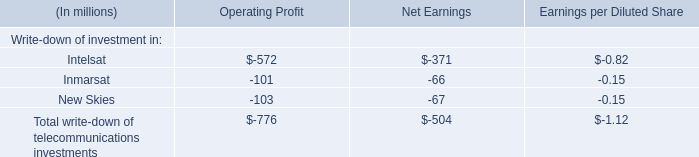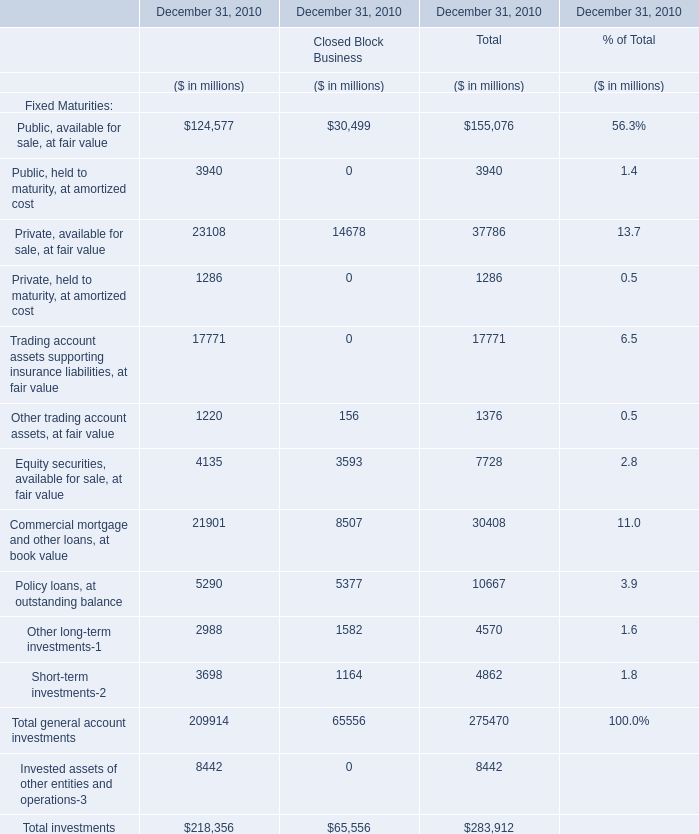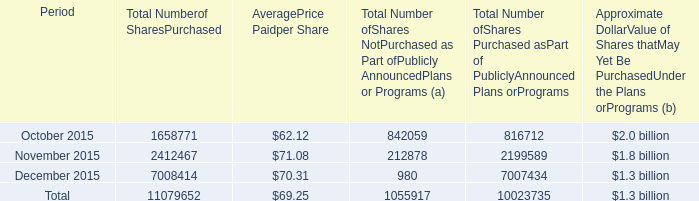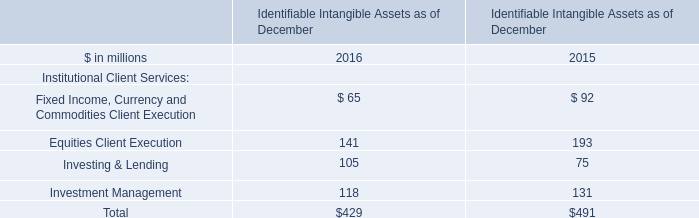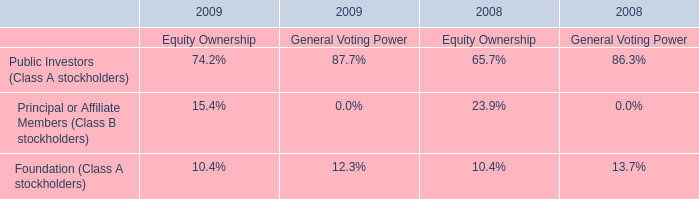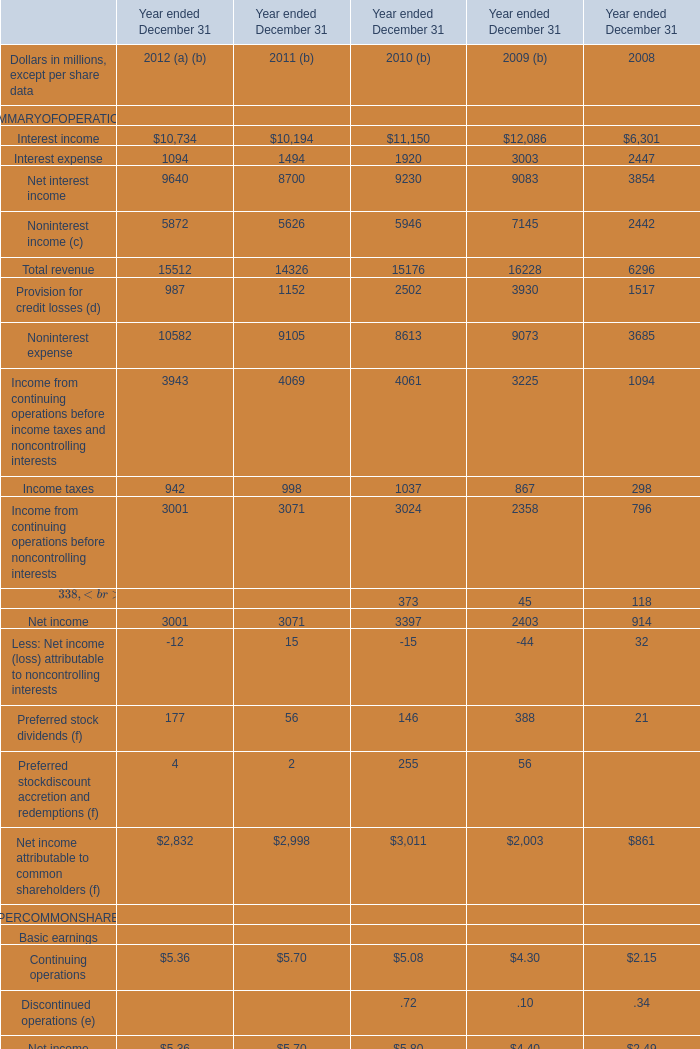What is the sum of Total revenue in 2008 and Investing & Lending in 2015? (in million) 
Computations: (6296 + 75)
Answer: 6371.0. 